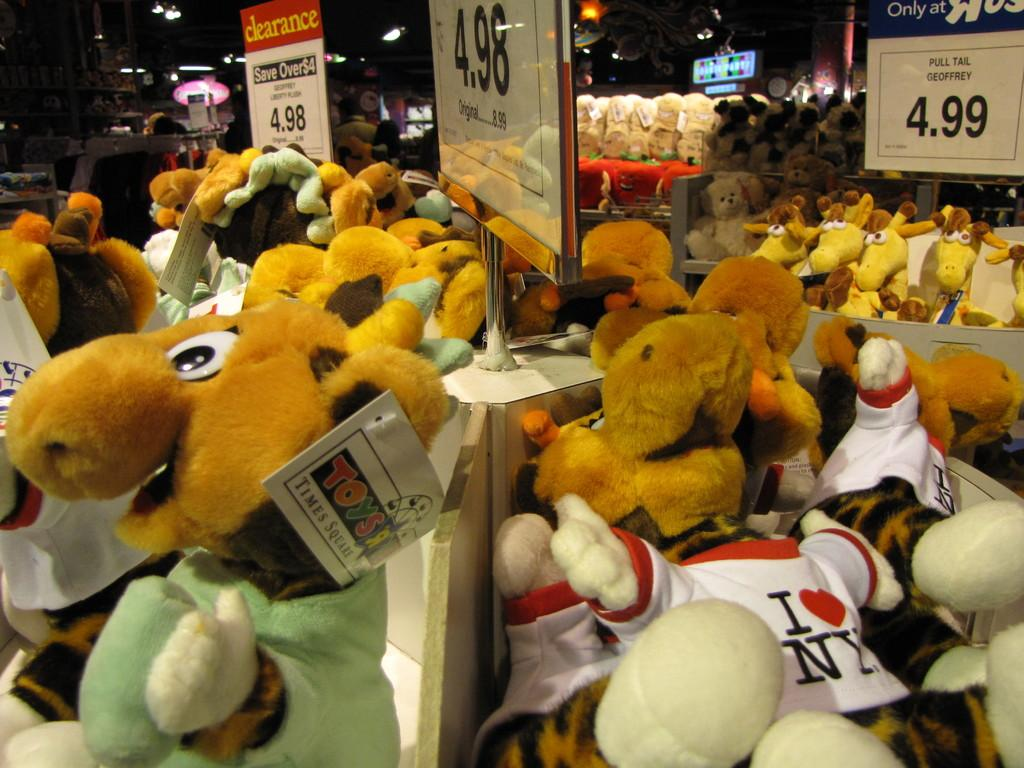What can be seen in large quantities in the image? There are many toys in the image. What objects are placed on tables in the image? There are boards placed on tables in the image. What is written or drawn on the boards? Text is visible on the boards. What can be seen in the background of the image? There are lights in the background of the image. What type of joke can be seen on the calculator in the image? There is no calculator present in the image, so it is not possible to determine if a joke is visible on one. 